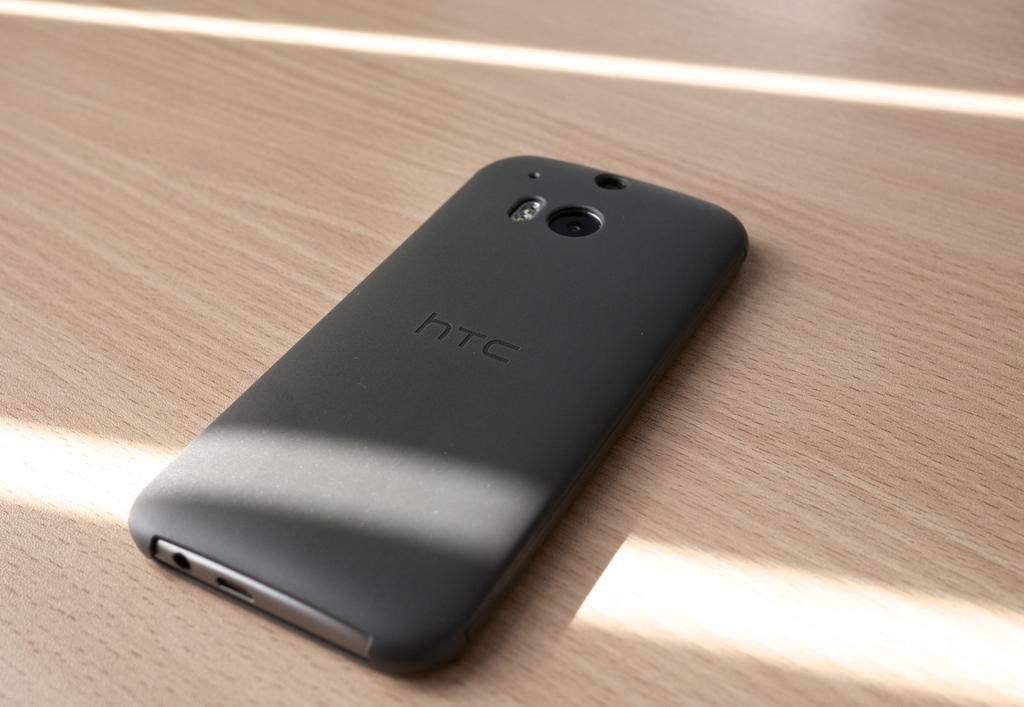Provide a one-sentence caption for the provided image. Back of a black HTC cellphone on a wooden table. 